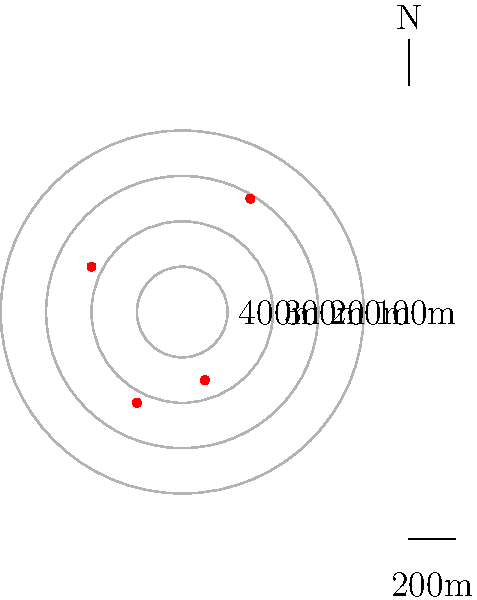You've discovered a volcanic island with unique mineral deposits. The topographic map shows contour lines at 100m intervals and red dots indicating mineral deposit locations. What is the approximate gradient (in degrees) between the highest point of the island and the mineral deposit located at coordinates (-0.4, 0.2)? To calculate the gradient between the highest point and the mineral deposit, we need to follow these steps:

1. Identify the highest point: The innermost contour represents the peak at 400m elevation.

2. Locate the mineral deposit: The deposit is at (-0.4, 0.2), which lies between the 300m and 200m contour lines.

3. Estimate the elevation of the mineral deposit: 
   It's closer to the 300m line, so we can estimate it at approximately 250m.

4. Calculate the elevation difference:
   $\Delta h = 400m - 250m = 150m$

5. Estimate the horizontal distance:
   The island's radius is about 0.8 units, and the deposit is about halfway from the center to the edge.
   So, the horizontal distance is approximately 0.4 * scale
   If the scale bar represents 200m for 0.2 units, then:
   $d = 0.4 * (200m / 0.2) = 400m$

6. Calculate the gradient angle using the arctangent function:
   $\theta = \arctan(\frac{\Delta h}{d}) = \arctan(\frac{150m}{400m})$

7. Convert to degrees:
   $\theta = \arctan(0.375) \approx 20.6°$
Answer: $20.6°$ 